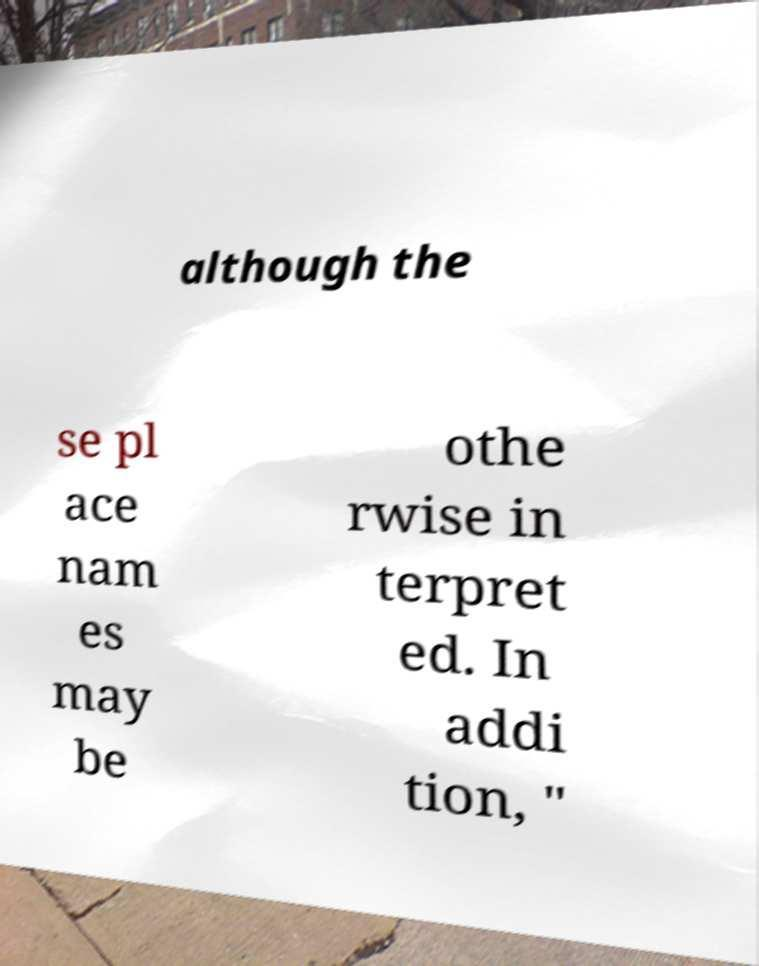What messages or text are displayed in this image? I need them in a readable, typed format. although the se pl ace nam es may be othe rwise in terpret ed. In addi tion, " 